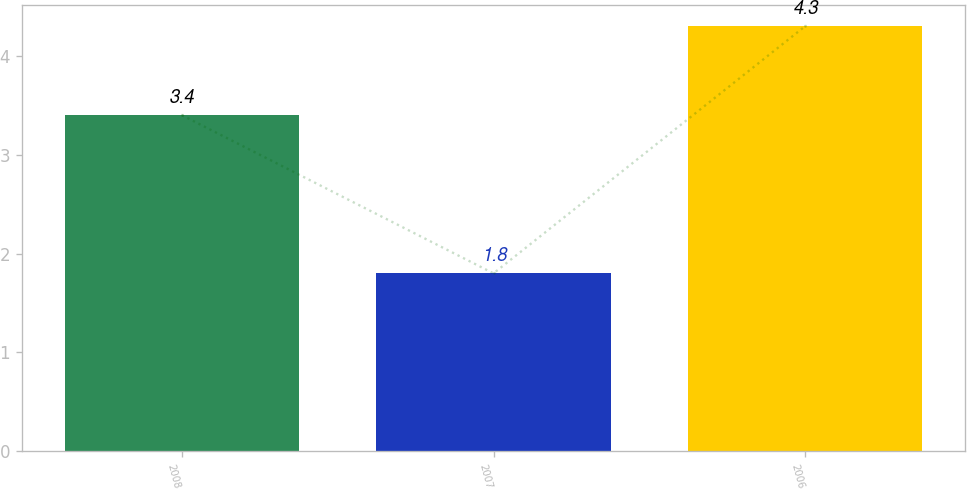<chart> <loc_0><loc_0><loc_500><loc_500><bar_chart><fcel>2008<fcel>2007<fcel>2006<nl><fcel>3.4<fcel>1.8<fcel>4.3<nl></chart> 